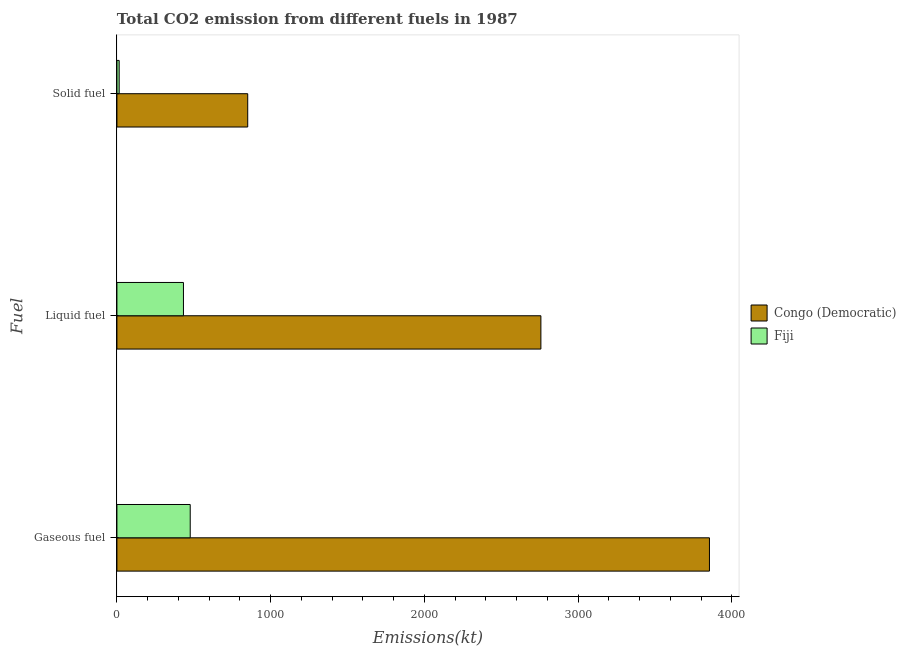Are the number of bars per tick equal to the number of legend labels?
Keep it short and to the point. Yes. How many bars are there on the 3rd tick from the top?
Your response must be concise. 2. What is the label of the 3rd group of bars from the top?
Make the answer very short. Gaseous fuel. What is the amount of co2 emissions from liquid fuel in Fiji?
Provide a succinct answer. 432.71. Across all countries, what is the maximum amount of co2 emissions from gaseous fuel?
Make the answer very short. 3854.02. Across all countries, what is the minimum amount of co2 emissions from liquid fuel?
Your answer should be very brief. 432.71. In which country was the amount of co2 emissions from solid fuel maximum?
Provide a succinct answer. Congo (Democratic). In which country was the amount of co2 emissions from liquid fuel minimum?
Your answer should be compact. Fiji. What is the total amount of co2 emissions from liquid fuel in the graph?
Your answer should be compact. 3190.29. What is the difference between the amount of co2 emissions from liquid fuel in Congo (Democratic) and that in Fiji?
Offer a terse response. 2324.88. What is the difference between the amount of co2 emissions from liquid fuel in Congo (Democratic) and the amount of co2 emissions from solid fuel in Fiji?
Offer a very short reply. 2742.92. What is the average amount of co2 emissions from liquid fuel per country?
Your answer should be very brief. 1595.15. What is the difference between the amount of co2 emissions from solid fuel and amount of co2 emissions from liquid fuel in Congo (Democratic)?
Provide a succinct answer. -1906.84. What is the ratio of the amount of co2 emissions from gaseous fuel in Fiji to that in Congo (Democratic)?
Provide a short and direct response. 0.12. Is the amount of co2 emissions from solid fuel in Fiji less than that in Congo (Democratic)?
Provide a succinct answer. Yes. What is the difference between the highest and the second highest amount of co2 emissions from gaseous fuel?
Give a very brief answer. 3377.31. What is the difference between the highest and the lowest amount of co2 emissions from solid fuel?
Make the answer very short. 836.08. In how many countries, is the amount of co2 emissions from gaseous fuel greater than the average amount of co2 emissions from gaseous fuel taken over all countries?
Provide a succinct answer. 1. Is the sum of the amount of co2 emissions from solid fuel in Congo (Democratic) and Fiji greater than the maximum amount of co2 emissions from liquid fuel across all countries?
Your answer should be very brief. No. What does the 1st bar from the top in Liquid fuel represents?
Provide a succinct answer. Fiji. What does the 1st bar from the bottom in Liquid fuel represents?
Give a very brief answer. Congo (Democratic). Is it the case that in every country, the sum of the amount of co2 emissions from gaseous fuel and amount of co2 emissions from liquid fuel is greater than the amount of co2 emissions from solid fuel?
Provide a succinct answer. Yes. How many bars are there?
Ensure brevity in your answer.  6. Are all the bars in the graph horizontal?
Make the answer very short. Yes. Are the values on the major ticks of X-axis written in scientific E-notation?
Give a very brief answer. No. How many legend labels are there?
Offer a terse response. 2. What is the title of the graph?
Give a very brief answer. Total CO2 emission from different fuels in 1987. What is the label or title of the X-axis?
Provide a short and direct response. Emissions(kt). What is the label or title of the Y-axis?
Provide a short and direct response. Fuel. What is the Emissions(kt) of Congo (Democratic) in Gaseous fuel?
Provide a short and direct response. 3854.02. What is the Emissions(kt) of Fiji in Gaseous fuel?
Give a very brief answer. 476.71. What is the Emissions(kt) in Congo (Democratic) in Liquid fuel?
Your answer should be compact. 2757.58. What is the Emissions(kt) in Fiji in Liquid fuel?
Provide a succinct answer. 432.71. What is the Emissions(kt) in Congo (Democratic) in Solid fuel?
Ensure brevity in your answer.  850.74. What is the Emissions(kt) of Fiji in Solid fuel?
Your answer should be compact. 14.67. Across all Fuel, what is the maximum Emissions(kt) of Congo (Democratic)?
Your answer should be very brief. 3854.02. Across all Fuel, what is the maximum Emissions(kt) in Fiji?
Provide a short and direct response. 476.71. Across all Fuel, what is the minimum Emissions(kt) of Congo (Democratic)?
Give a very brief answer. 850.74. Across all Fuel, what is the minimum Emissions(kt) in Fiji?
Make the answer very short. 14.67. What is the total Emissions(kt) in Congo (Democratic) in the graph?
Offer a very short reply. 7462.35. What is the total Emissions(kt) of Fiji in the graph?
Your answer should be compact. 924.08. What is the difference between the Emissions(kt) of Congo (Democratic) in Gaseous fuel and that in Liquid fuel?
Make the answer very short. 1096.43. What is the difference between the Emissions(kt) in Fiji in Gaseous fuel and that in Liquid fuel?
Your response must be concise. 44. What is the difference between the Emissions(kt) of Congo (Democratic) in Gaseous fuel and that in Solid fuel?
Offer a very short reply. 3003.27. What is the difference between the Emissions(kt) of Fiji in Gaseous fuel and that in Solid fuel?
Keep it short and to the point. 462.04. What is the difference between the Emissions(kt) in Congo (Democratic) in Liquid fuel and that in Solid fuel?
Your response must be concise. 1906.84. What is the difference between the Emissions(kt) in Fiji in Liquid fuel and that in Solid fuel?
Your response must be concise. 418.04. What is the difference between the Emissions(kt) in Congo (Democratic) in Gaseous fuel and the Emissions(kt) in Fiji in Liquid fuel?
Offer a terse response. 3421.31. What is the difference between the Emissions(kt) of Congo (Democratic) in Gaseous fuel and the Emissions(kt) of Fiji in Solid fuel?
Keep it short and to the point. 3839.35. What is the difference between the Emissions(kt) of Congo (Democratic) in Liquid fuel and the Emissions(kt) of Fiji in Solid fuel?
Offer a very short reply. 2742.92. What is the average Emissions(kt) in Congo (Democratic) per Fuel?
Keep it short and to the point. 2487.45. What is the average Emissions(kt) of Fiji per Fuel?
Give a very brief answer. 308.03. What is the difference between the Emissions(kt) of Congo (Democratic) and Emissions(kt) of Fiji in Gaseous fuel?
Your response must be concise. 3377.31. What is the difference between the Emissions(kt) in Congo (Democratic) and Emissions(kt) in Fiji in Liquid fuel?
Your answer should be very brief. 2324.88. What is the difference between the Emissions(kt) of Congo (Democratic) and Emissions(kt) of Fiji in Solid fuel?
Offer a terse response. 836.08. What is the ratio of the Emissions(kt) of Congo (Democratic) in Gaseous fuel to that in Liquid fuel?
Your answer should be very brief. 1.4. What is the ratio of the Emissions(kt) of Fiji in Gaseous fuel to that in Liquid fuel?
Keep it short and to the point. 1.1. What is the ratio of the Emissions(kt) of Congo (Democratic) in Gaseous fuel to that in Solid fuel?
Offer a very short reply. 4.53. What is the ratio of the Emissions(kt) of Fiji in Gaseous fuel to that in Solid fuel?
Keep it short and to the point. 32.5. What is the ratio of the Emissions(kt) of Congo (Democratic) in Liquid fuel to that in Solid fuel?
Ensure brevity in your answer.  3.24. What is the ratio of the Emissions(kt) of Fiji in Liquid fuel to that in Solid fuel?
Provide a succinct answer. 29.5. What is the difference between the highest and the second highest Emissions(kt) of Congo (Democratic)?
Ensure brevity in your answer.  1096.43. What is the difference between the highest and the second highest Emissions(kt) in Fiji?
Provide a short and direct response. 44. What is the difference between the highest and the lowest Emissions(kt) in Congo (Democratic)?
Give a very brief answer. 3003.27. What is the difference between the highest and the lowest Emissions(kt) of Fiji?
Keep it short and to the point. 462.04. 